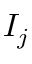<formula> <loc_0><loc_0><loc_500><loc_500>I _ { j }</formula> 